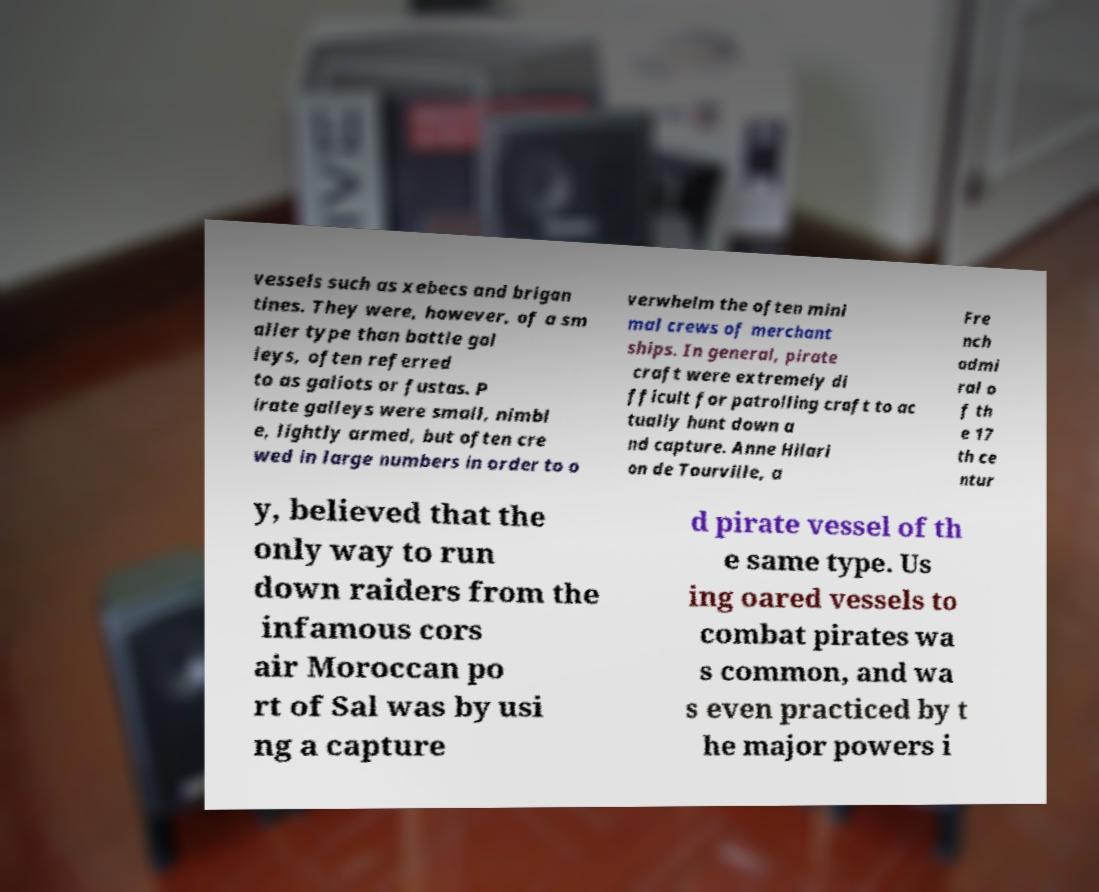Please identify and transcribe the text found in this image. vessels such as xebecs and brigan tines. They were, however, of a sm aller type than battle gal leys, often referred to as galiots or fustas. P irate galleys were small, nimbl e, lightly armed, but often cre wed in large numbers in order to o verwhelm the often mini mal crews of merchant ships. In general, pirate craft were extremely di fficult for patrolling craft to ac tually hunt down a nd capture. Anne Hilari on de Tourville, a Fre nch admi ral o f th e 17 th ce ntur y, believed that the only way to run down raiders from the infamous cors air Moroccan po rt of Sal was by usi ng a capture d pirate vessel of th e same type. Us ing oared vessels to combat pirates wa s common, and wa s even practiced by t he major powers i 